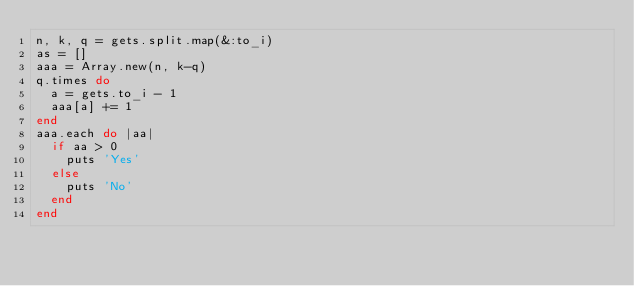<code> <loc_0><loc_0><loc_500><loc_500><_Ruby_>n, k, q = gets.split.map(&:to_i)
as = []
aaa = Array.new(n, k-q)
q.times do
  a = gets.to_i - 1
  aaa[a] += 1
end
aaa.each do |aa|
  if aa > 0
    puts 'Yes'
  else
    puts 'No'
  end
end</code> 